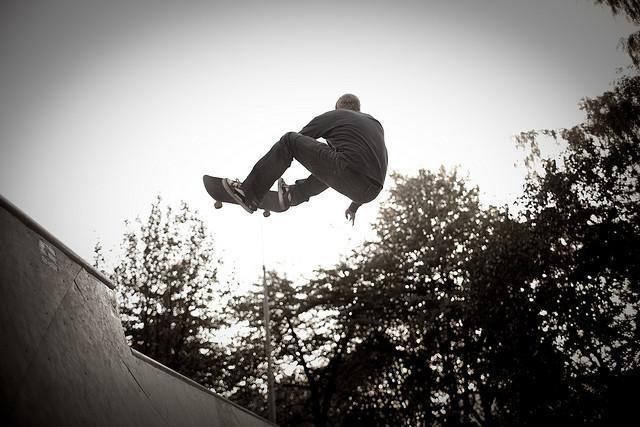How many cows are walking in the road?
Give a very brief answer. 0. 